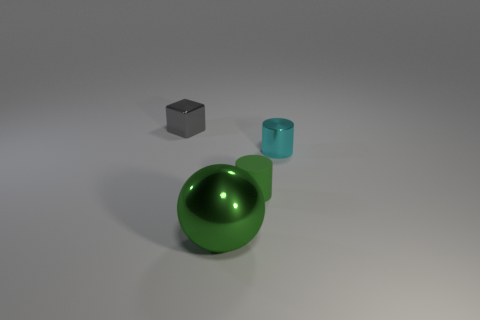Add 3 tiny gray shiny blocks. How many objects exist? 7 Add 3 small green cylinders. How many small green cylinders exist? 4 Subtract 0 purple cylinders. How many objects are left? 4 Subtract all gray objects. Subtract all small cylinders. How many objects are left? 1 Add 3 large green shiny objects. How many large green shiny objects are left? 4 